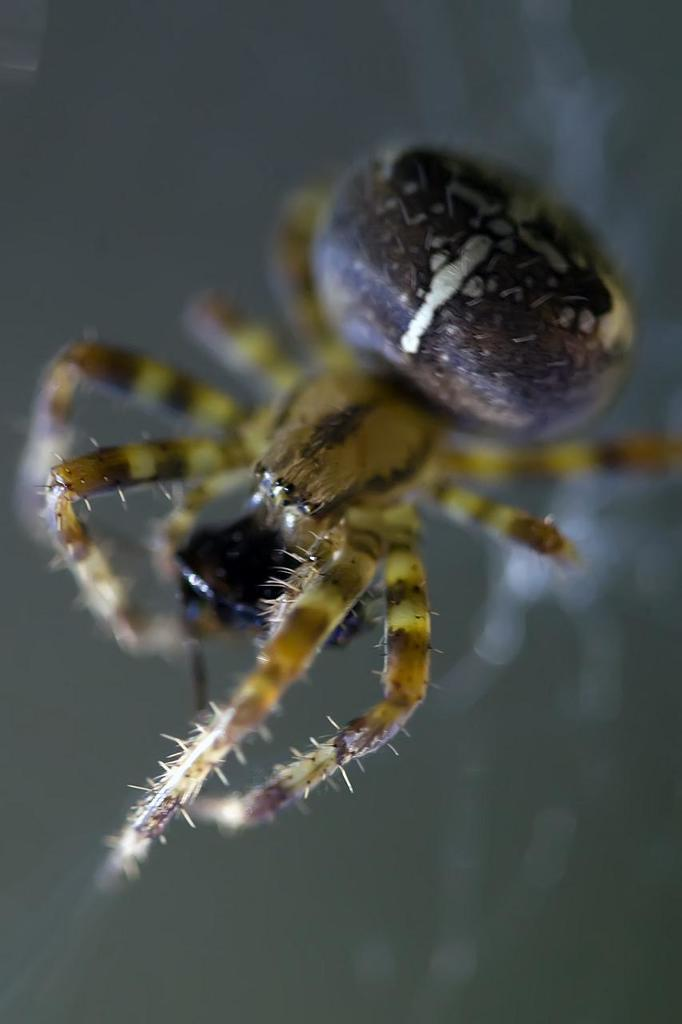What is the main subject of the image? There is a spider in the image. Can you describe the background of the image? The background of the image is blurred. How many geese are visible in the image? There are no geese present in the image; it features a spider. What angle is the spider positioned at in the image? The angle at which the spider is positioned cannot be determined from the image alone, as it only provides a two-dimensional representation. 